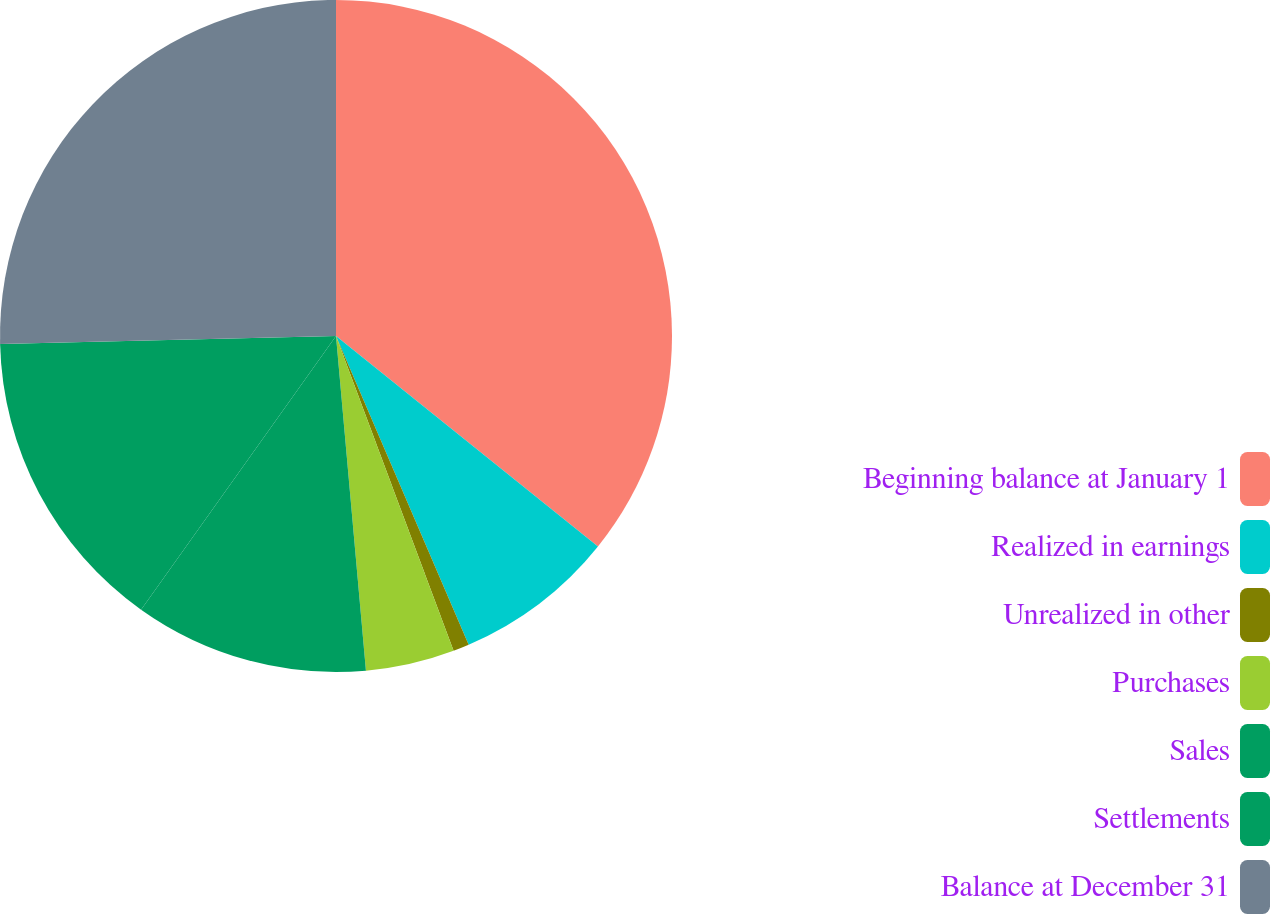<chart> <loc_0><loc_0><loc_500><loc_500><pie_chart><fcel>Beginning balance at January 1<fcel>Realized in earnings<fcel>Unrealized in other<fcel>Purchases<fcel>Sales<fcel>Settlements<fcel>Balance at December 31<nl><fcel>35.77%<fcel>7.77%<fcel>0.77%<fcel>4.27%<fcel>11.27%<fcel>14.77%<fcel>25.38%<nl></chart> 